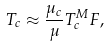<formula> <loc_0><loc_0><loc_500><loc_500>T _ { c } \approx \frac { \mu _ { c } } \mu T _ { c } ^ { M } F ,</formula> 